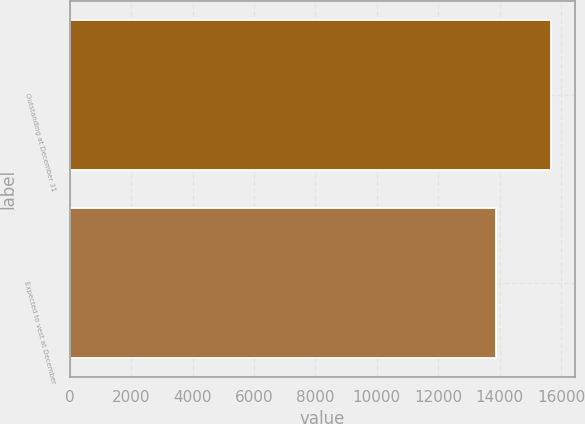Convert chart. <chart><loc_0><loc_0><loc_500><loc_500><bar_chart><fcel>Outstanding at December 31<fcel>Expected to vest at December<nl><fcel>15677<fcel>13894<nl></chart> 